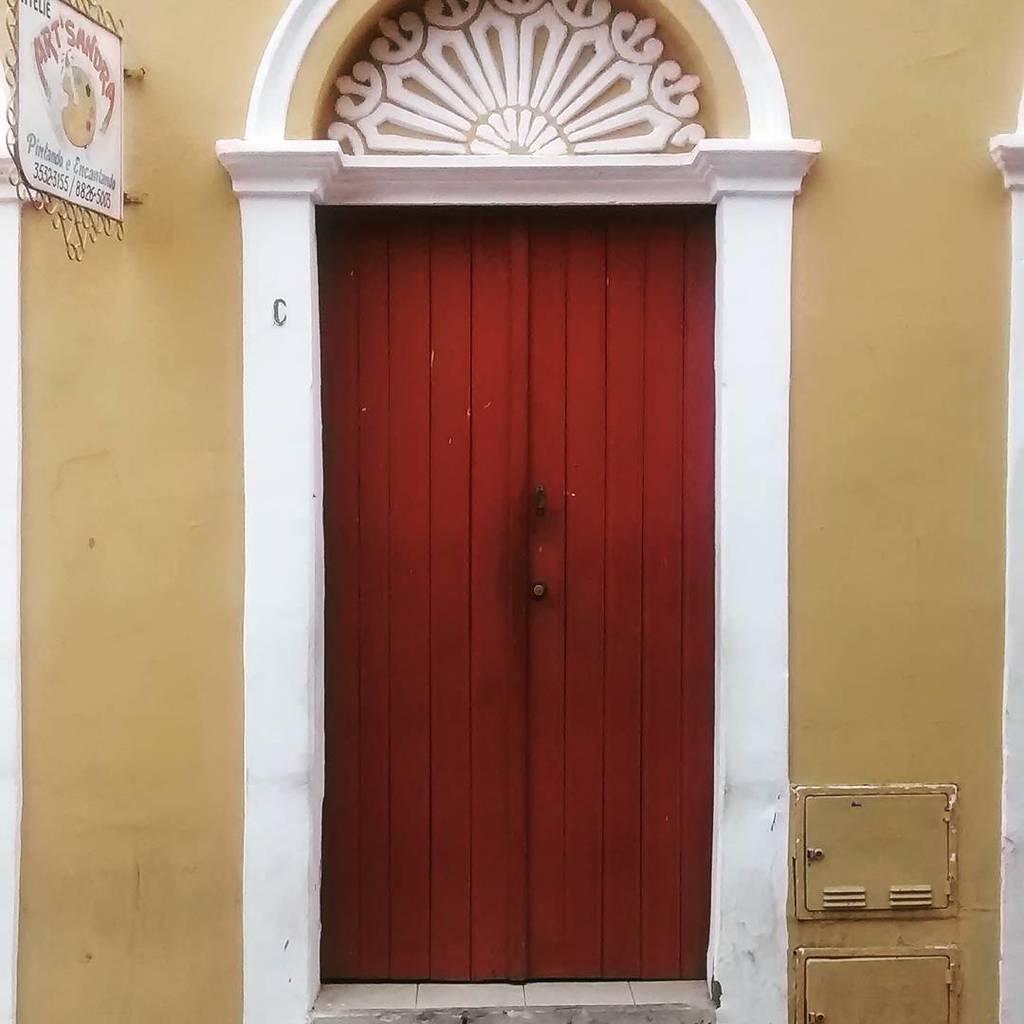Describe this image in one or two sentences. In this image, we can see a door, walls, board and few objects. On this board, we can see some text and figure. 